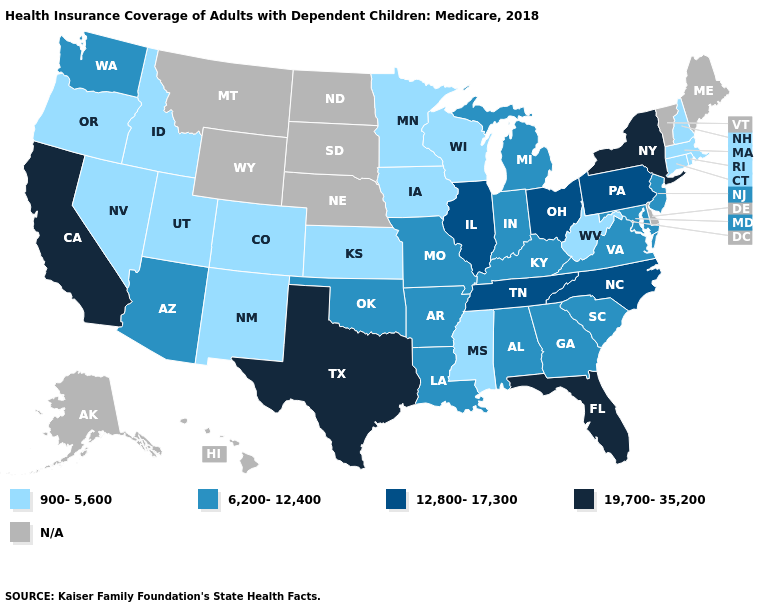Name the states that have a value in the range 12,800-17,300?
Keep it brief. Illinois, North Carolina, Ohio, Pennsylvania, Tennessee. What is the highest value in states that border Nebraska?
Short answer required. 6,200-12,400. What is the value of Arkansas?
Keep it brief. 6,200-12,400. What is the value of Minnesota?
Be succinct. 900-5,600. Does the first symbol in the legend represent the smallest category?
Keep it brief. Yes. Which states have the lowest value in the South?
Give a very brief answer. Mississippi, West Virginia. Name the states that have a value in the range 6,200-12,400?
Answer briefly. Alabama, Arizona, Arkansas, Georgia, Indiana, Kentucky, Louisiana, Maryland, Michigan, Missouri, New Jersey, Oklahoma, South Carolina, Virginia, Washington. What is the highest value in the MidWest ?
Give a very brief answer. 12,800-17,300. What is the value of Colorado?
Concise answer only. 900-5,600. Which states have the highest value in the USA?
Concise answer only. California, Florida, New York, Texas. What is the value of Michigan?
Be succinct. 6,200-12,400. Among the states that border Texas , does New Mexico have the lowest value?
Be succinct. Yes. How many symbols are there in the legend?
Concise answer only. 5. 